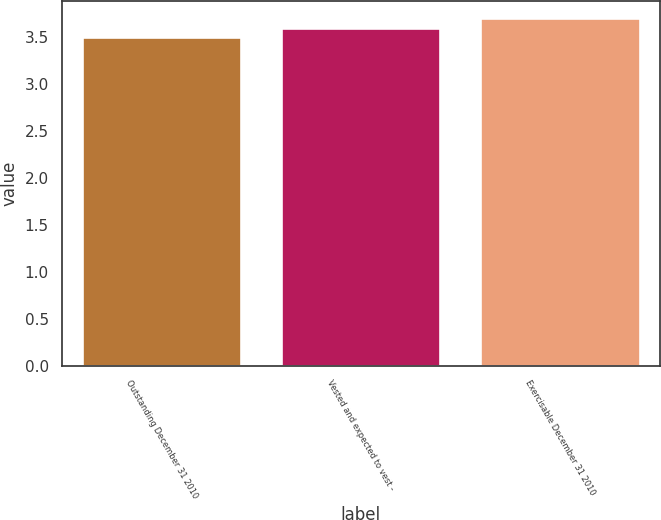<chart> <loc_0><loc_0><loc_500><loc_500><bar_chart><fcel>Outstanding December 31 2010<fcel>Vested and expected to vest -<fcel>Exercisable December 31 2010<nl><fcel>3.5<fcel>3.6<fcel>3.7<nl></chart> 